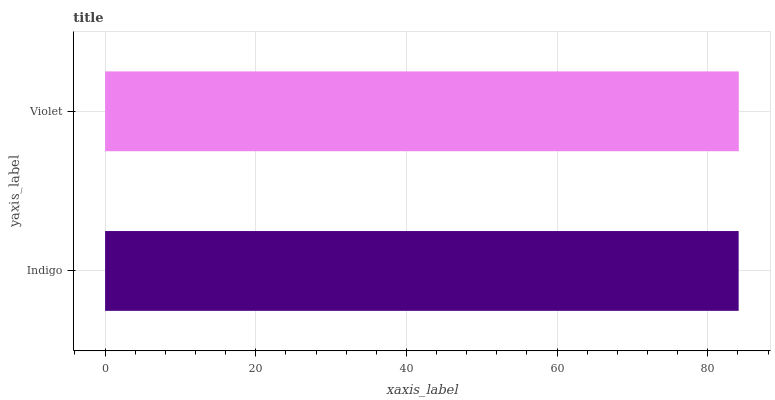Is Indigo the minimum?
Answer yes or no. Yes. Is Violet the maximum?
Answer yes or no. Yes. Is Violet the minimum?
Answer yes or no. No. Is Violet greater than Indigo?
Answer yes or no. Yes. Is Indigo less than Violet?
Answer yes or no. Yes. Is Indigo greater than Violet?
Answer yes or no. No. Is Violet less than Indigo?
Answer yes or no. No. Is Violet the high median?
Answer yes or no. Yes. Is Indigo the low median?
Answer yes or no. Yes. Is Indigo the high median?
Answer yes or no. No. Is Violet the low median?
Answer yes or no. No. 